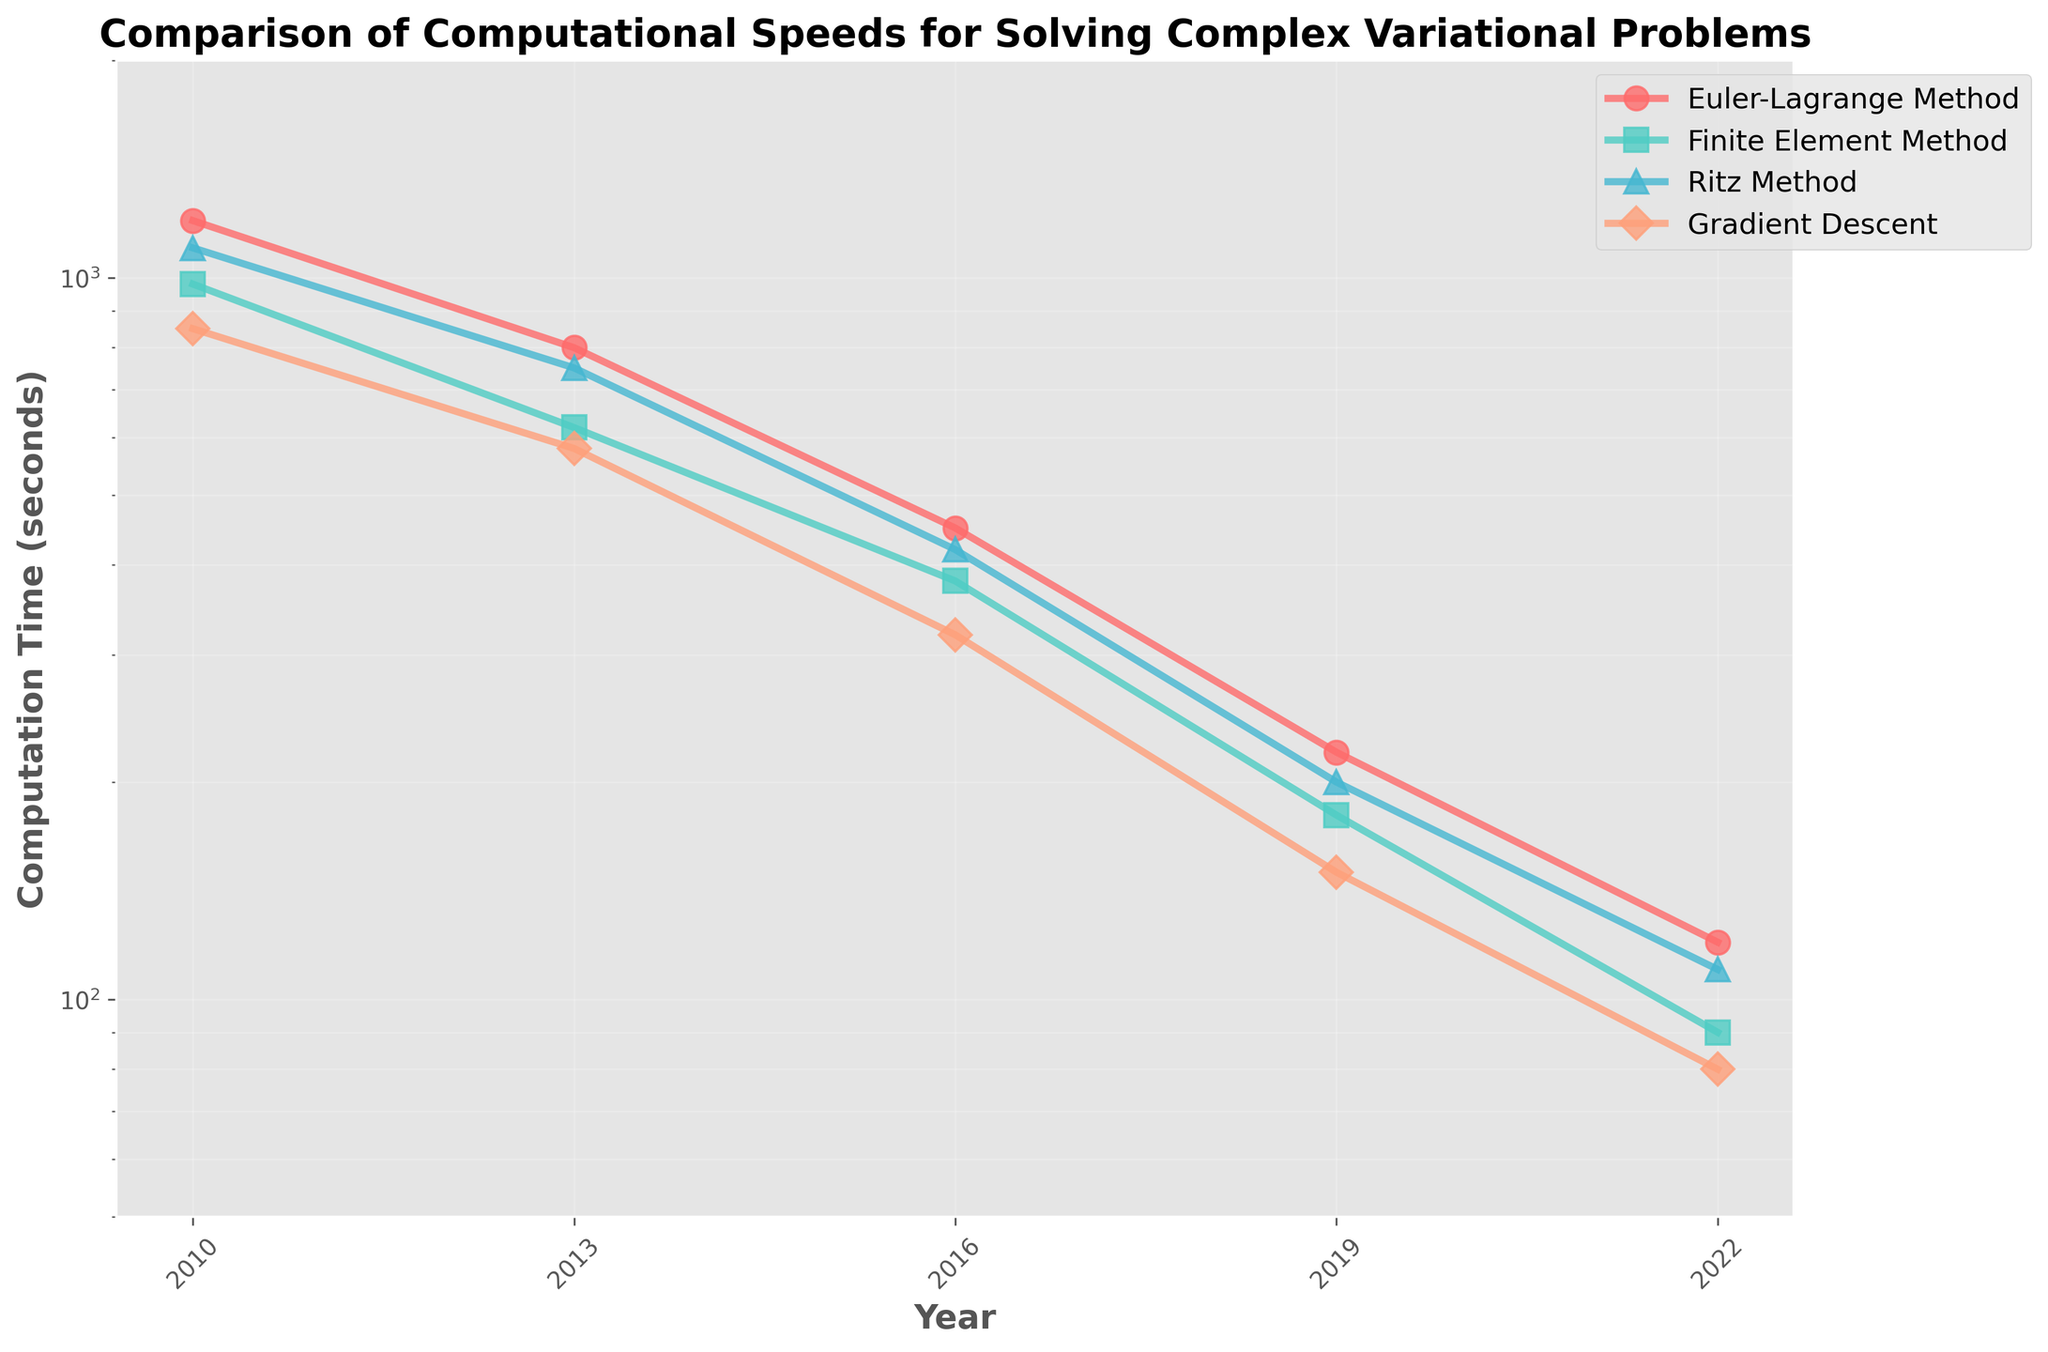What was the computation time for the Euler-Lagrange method in 2022? Look at the plot line representing the Euler-Lagrange method for the year 2022, and read the corresponding computation time on the y-axis.
Answer: 120 seconds Which algorithm showed the most significant reduction in computation time from 2010 to 2022? Compare the computation times for all algorithms in 2010 and 2022 and identify which one had the largest decrease. Euler-Lagrange decreased from 1200 to 120, Finite Element from 980 to 90, Ritz from 1100 to 110, and Gradient Descent from 850 to 80. The Euler-Lagrange method had the largest reduction.
Answer: Euler-Lagrange Method Between 2013 and 2016, which algorithm had the smallest decrease in computation time? Calculate the decrease in computation time for each algorithm between 2013 and 2016 and determine the smallest one. Euler-Lagrange: 800 to 450 (350), Finite Element: 620 to 380 (240), Ritz: 750 to 420 (330), Gradient Descent: 580 to 320 (260). The Finite Element Method had the smallest decrease.
Answer: Finite Element Method What are the primary colors used to represent each algorithm in the plot? Identify the colors of the lines representing each algorithm. The Euler-Lagrange Method is red, the Finite Element Method is green, the Ritz Method is blue, and the Gradient Descent is orange.
Answer: Red, green, blue, and orange By what percent did the computation time for the Gradient Descent algorithm decrease from 2010 to 2022? Calculate the percentage decrease from 2010 to 2022 using the formula: ((850 - 80) / 850) * 100%. The decrease is ((850 - 80) / 850) * 100% = 90.59%.
Answer: 90.59% Which year saw the largest overall decrease in computation time across all algorithms from the previous year? Analyze the drop in computation time for each algorithm from one year to the next and sum these drops for each year interval. The highest sum will indicate the largest overall decrease.
Answer: 2013-2016 How do the computation times for the Finite Element method compare in 2016 and 2022? Look at the data points for the Finite Element Method for the years 2016 and 2022 and compare their y-axis values.
Answer: 380 seconds in 2016; 90 seconds in 2022 What was the relative ranking of the computation times for all four methods in 2010? Compare the computation times for all four methods for the year 2010 and rank them from lowest to highest.
Answer: Gradient Descent < Finite Element Method < Ritz Method < Euler-Lagrange Method What is the average computation time for the Ritz method over the years presented? Calculate the average by summing the computation times for the years 2010, 2013, 2016, 2019, and 2022, and dividing by the number of years. (1100 + 750 + 420 + 200 + 110) / 5 = 516 seconds.
Answer: 516 seconds 